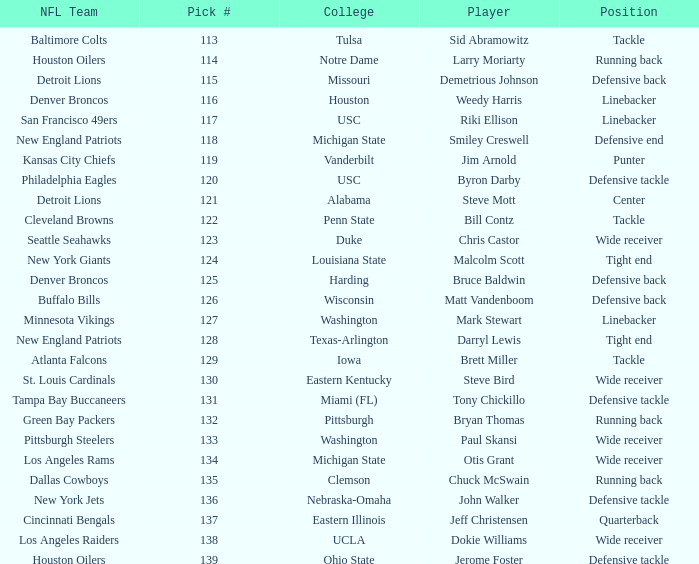What is the highest pick number the los angeles raiders got? 138.0. 